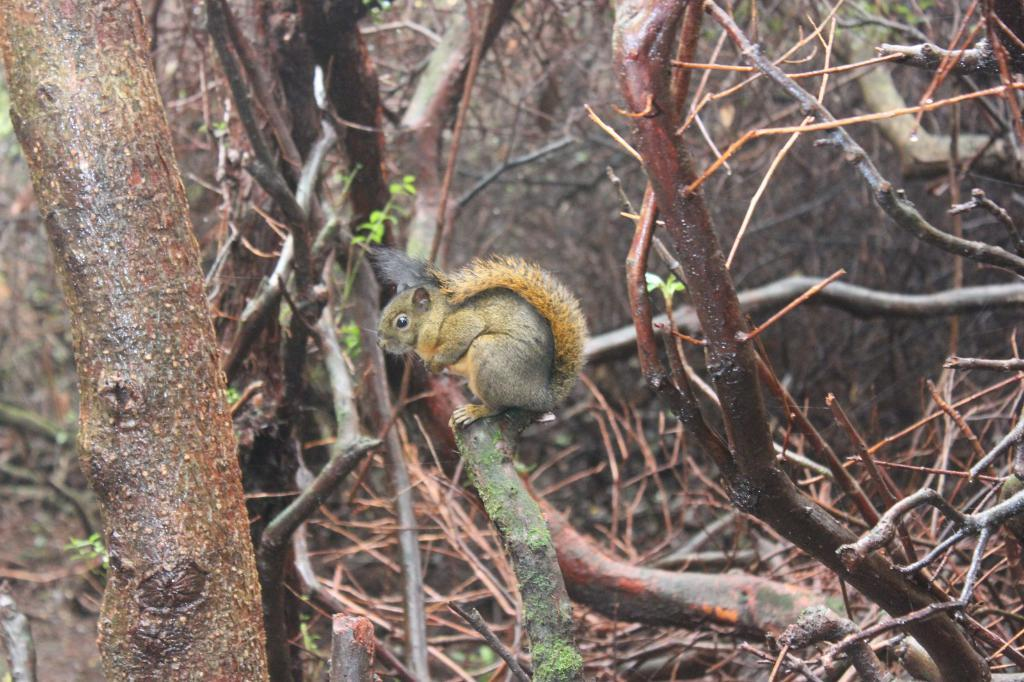What animal can be seen in the image? There is a squirrel in the image. Where is the squirrel located? The squirrel is on a tree. Can you describe the position of the tree in the image? The tree is in the center of the image. What type of flame can be seen on the squirrel's tail in the image? There is no flame present on the squirrel's tail in the image. 